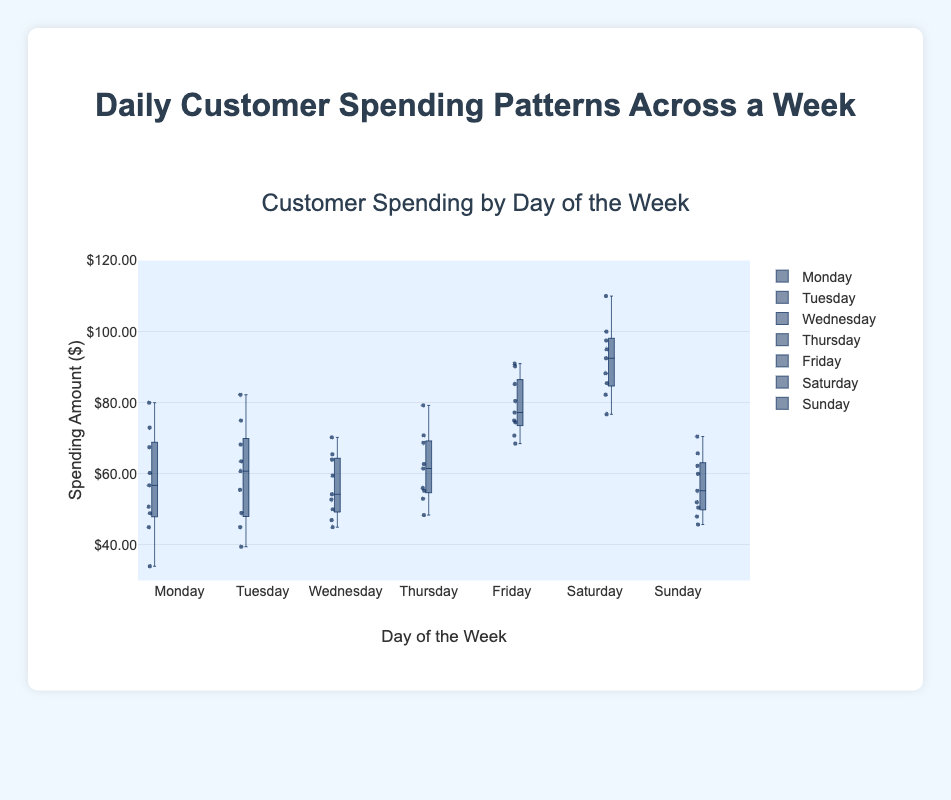what is the title of the plot? The title is usually displayed at the top of the plot in a larger font size for clarity. Here, it is "Customer Spending by Day of the Week".
Answer: Customer Spending by Day of the Week Which day has the highest median customer spending? Look at the middle line of each box plot, which represents the median. The highest median value is observed on Saturday.
Answer: Saturday What is the range of spending on Friday? The range is the difference between the highest and lowest values in the box plot for Friday. From the whiskers, the highest value is 91.00 and the lowest value is 68.50. So, the range is 91.00 - 68.50.
Answer: 22.50 On which day is customer spending the most spread out? Look for the box plot with the longest distance between the whiskers. Saturday has the most spread-out (longest) whiskers and interquartile range.
Answer: Saturday What is the median value of customer spending on Monday? To find the median, look at the middle line of the box plot for Monday. Here, it is approximately 56.75.
Answer: 56.75 Which day has the lowest minimum customer spending? The minimum is represented by the lowest point of the whiskers or outliers. On Monday, the minimum value is 34.00, which is the lowest compared with other days.
Answer: Monday What is the interquartile range (IQR) for Tuesday? The IQR is the difference between the upper quartile (top of the box) and the lower quartile (bottom of the box). For Tuesday, the upper quartile is around 68.25 and the lower quartile is around 45. So, the IQR is 68.25 - 45.
Answer: 23.25 How do the spending patterns on Sunday compare with those on Wednesday? Compare the medians, interquartile ranges, and whiskers of the box plots for Sunday and Wednesday. Sunday generally has lower spending, with a lower median and more compact interquartile range, compared to Wednesday.
Answer: Lower median and compact IQR on Sunday What is the median customer spending on Friday, and how does it compare to Wednesday? Identify the median lines for both Friday and Wednesday. The median for Friday is approximately 75.00, and for Wednesday, it is around 54.25. Friday's median is higher than Wednesday's.
Answer: Friday's median is higher Which day shows the highest variability in customer spending and what indicates this? High variability is indicated by a large interquartile range and long whiskers. Saturday shows the highest variability, evident from its widest box and longest whiskers.
Answer: Saturday 